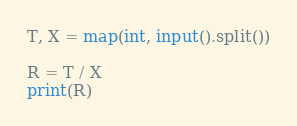Convert code to text. <code><loc_0><loc_0><loc_500><loc_500><_Python_>T, X = map(int, input().split())

R = T / X
print(R)</code> 